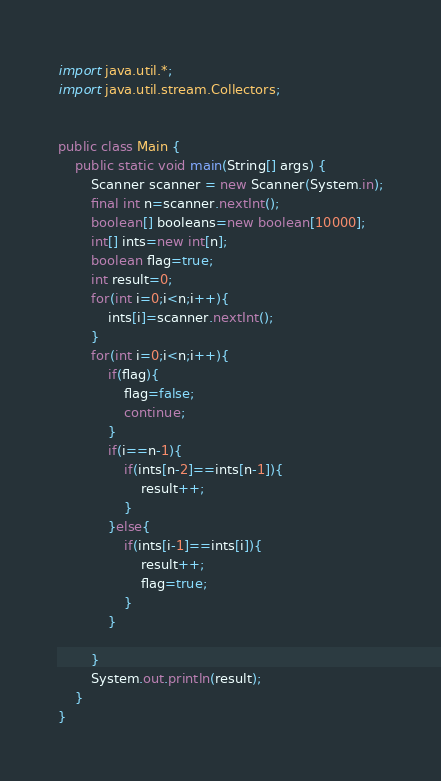Convert code to text. <code><loc_0><loc_0><loc_500><loc_500><_Java_>
import java.util.*;
import java.util.stream.Collectors;


public class Main {
    public static void main(String[] args) {
        Scanner scanner = new Scanner(System.in);
        final int n=scanner.nextInt();
        boolean[] booleans=new boolean[10000];
        int[] ints=new int[n];
        boolean flag=true;
        int result=0;
        for(int i=0;i<n;i++){
            ints[i]=scanner.nextInt();
        }
        for(int i=0;i<n;i++){
            if(flag){
                flag=false;
                continue;
            }
            if(i==n-1){
                if(ints[n-2]==ints[n-1]){
                    result++;
                }
            }else{
                if(ints[i-1]==ints[i]){
                    result++;
                    flag=true;
                }
            }

        }
        System.out.println(result);
    }
}</code> 